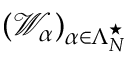<formula> <loc_0><loc_0><loc_500><loc_500>( { \ m a t h s c r W } _ { \alpha } ) _ { \alpha \in \Lambda _ { N } ^ { ^ { * } } }</formula> 